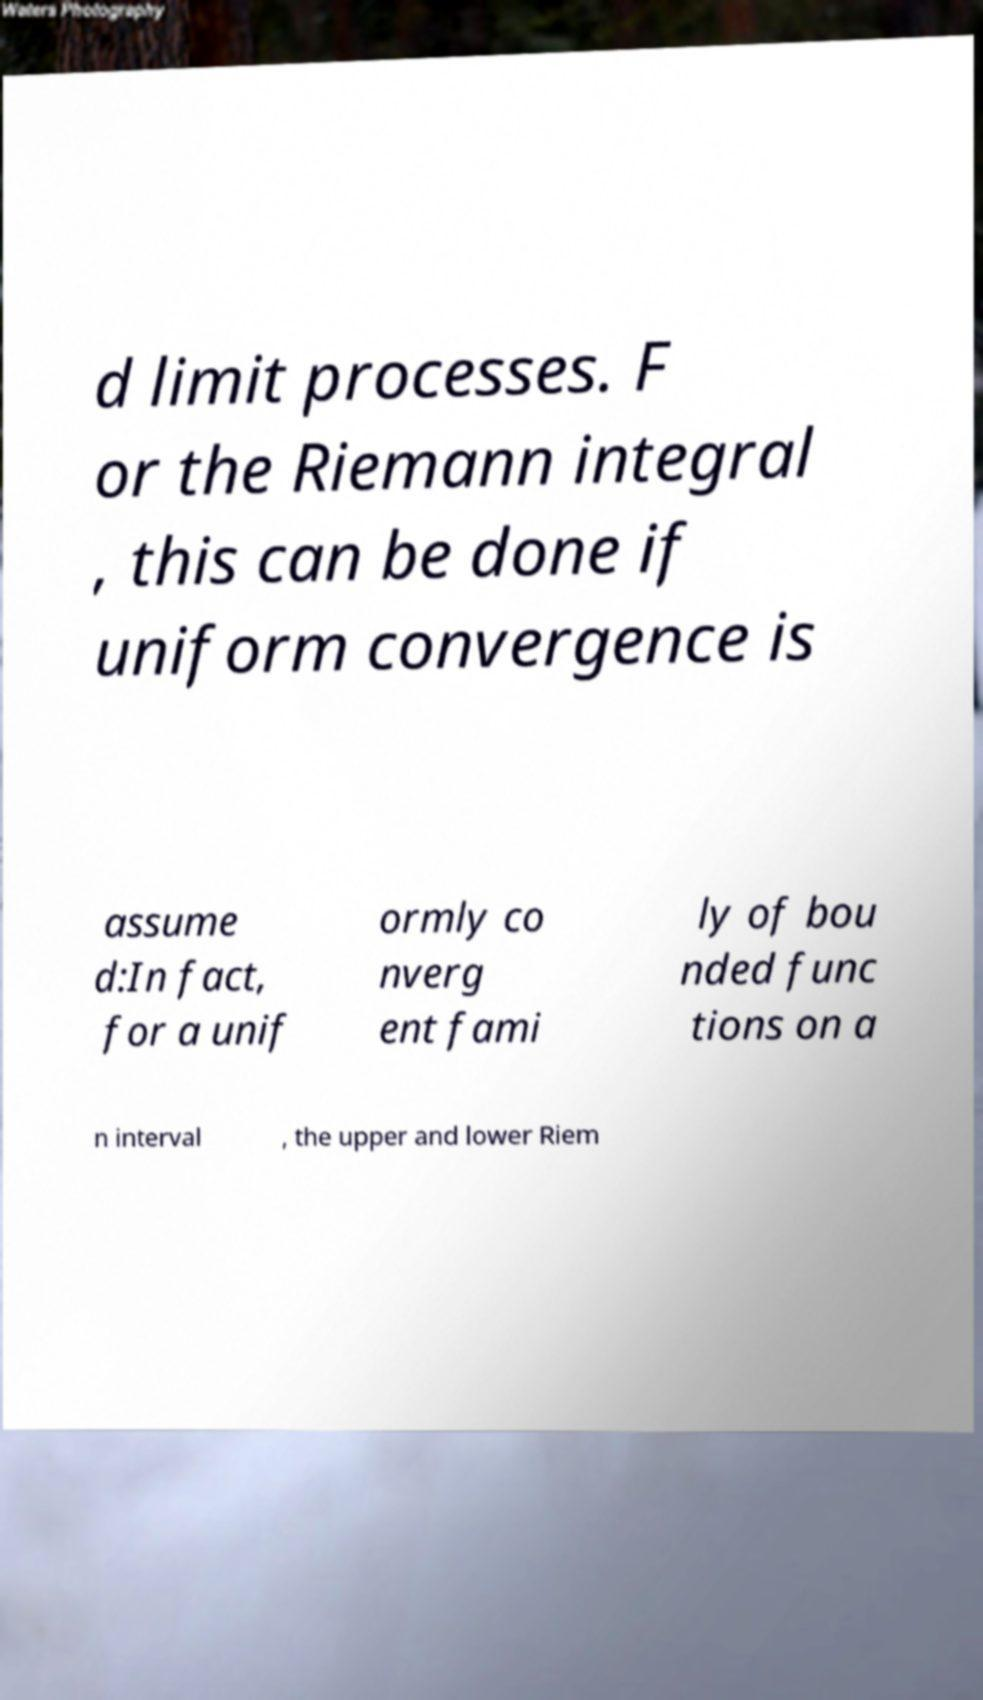There's text embedded in this image that I need extracted. Can you transcribe it verbatim? d limit processes. F or the Riemann integral , this can be done if uniform convergence is assume d:In fact, for a unif ormly co nverg ent fami ly of bou nded func tions on a n interval , the upper and lower Riem 